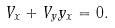<formula> <loc_0><loc_0><loc_500><loc_500>V _ { x } + V _ { y } y _ { x } = 0 .</formula> 